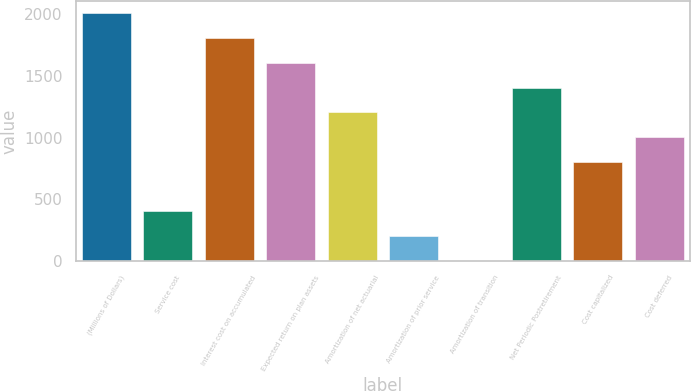Convert chart. <chart><loc_0><loc_0><loc_500><loc_500><bar_chart><fcel>(Millions of Dollars)<fcel>Service cost<fcel>Interest cost on accumulated<fcel>Expected return on plan assets<fcel>Amortization of net actuarial<fcel>Amortization of prior service<fcel>Amortization of transition<fcel>Net Periodic Postretirement<fcel>Cost capitalized<fcel>Cost deferred<nl><fcel>2006<fcel>404.4<fcel>1805.8<fcel>1605.6<fcel>1205.2<fcel>204.2<fcel>4<fcel>1405.4<fcel>804.8<fcel>1005<nl></chart> 